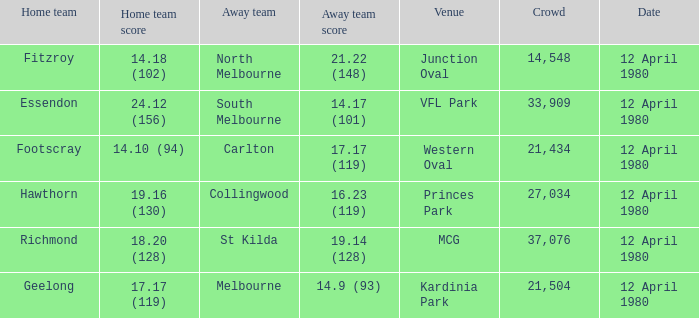Where did Essendon play as the home team? VFL Park. Parse the table in full. {'header': ['Home team', 'Home team score', 'Away team', 'Away team score', 'Venue', 'Crowd', 'Date'], 'rows': [['Fitzroy', '14.18 (102)', 'North Melbourne', '21.22 (148)', 'Junction Oval', '14,548', '12 April 1980'], ['Essendon', '24.12 (156)', 'South Melbourne', '14.17 (101)', 'VFL Park', '33,909', '12 April 1980'], ['Footscray', '14.10 (94)', 'Carlton', '17.17 (119)', 'Western Oval', '21,434', '12 April 1980'], ['Hawthorn', '19.16 (130)', 'Collingwood', '16.23 (119)', 'Princes Park', '27,034', '12 April 1980'], ['Richmond', '18.20 (128)', 'St Kilda', '19.14 (128)', 'MCG', '37,076', '12 April 1980'], ['Geelong', '17.17 (119)', 'Melbourne', '14.9 (93)', 'Kardinia Park', '21,504', '12 April 1980']]} 